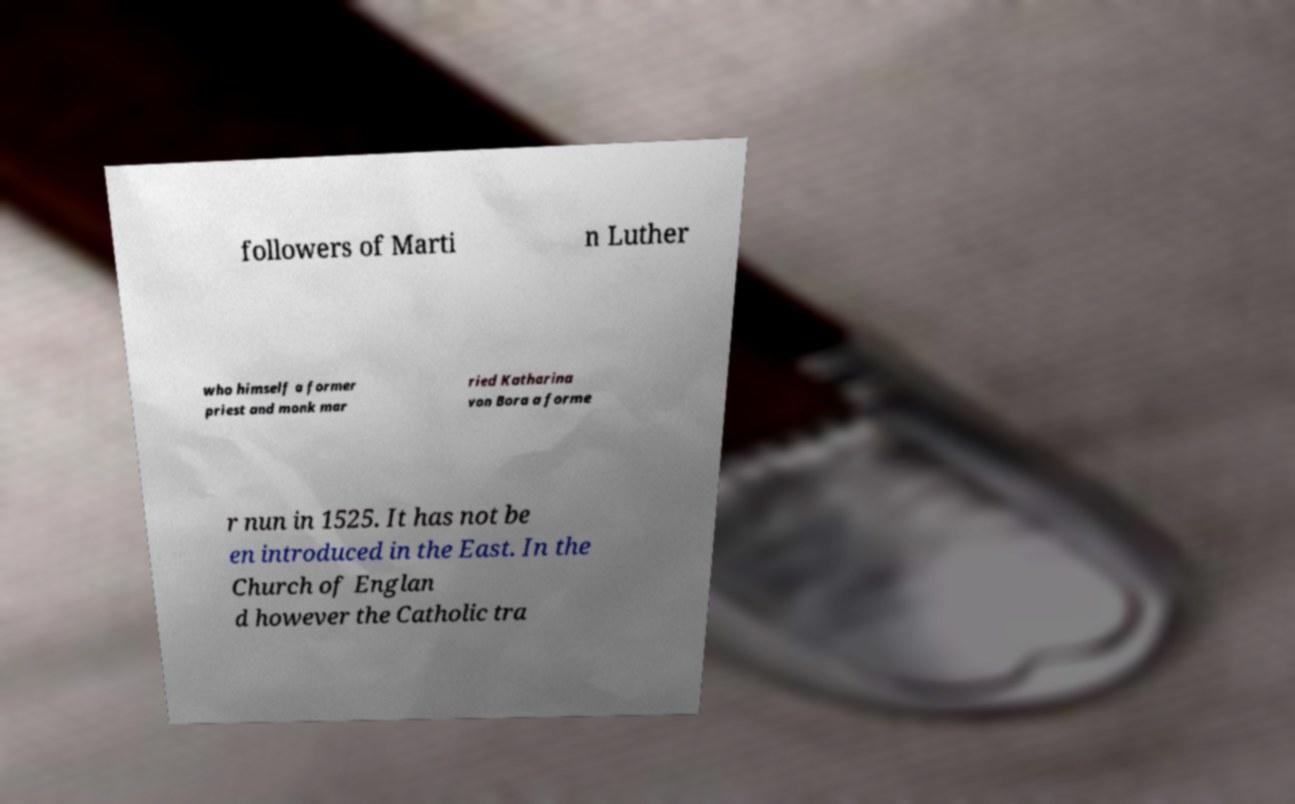Could you assist in decoding the text presented in this image and type it out clearly? followers of Marti n Luther who himself a former priest and monk mar ried Katharina von Bora a forme r nun in 1525. It has not be en introduced in the East. In the Church of Englan d however the Catholic tra 